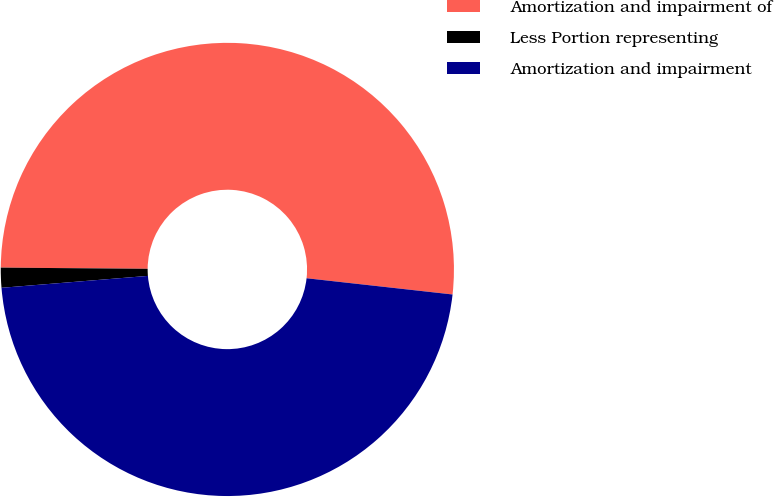Convert chart. <chart><loc_0><loc_0><loc_500><loc_500><pie_chart><fcel>Amortization and impairment of<fcel>Less Portion representing<fcel>Amortization and impairment<nl><fcel>51.64%<fcel>1.42%<fcel>46.95%<nl></chart> 